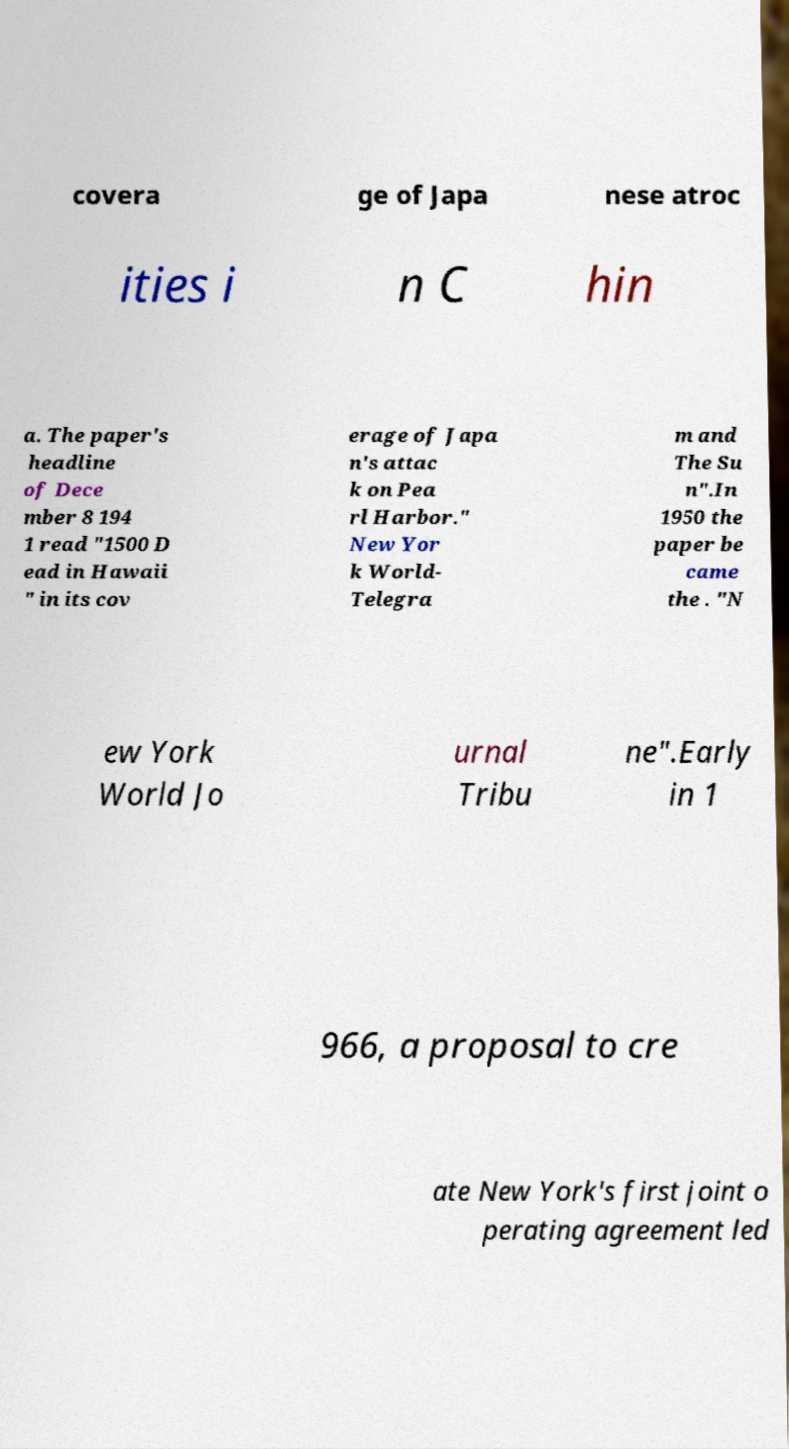Please identify and transcribe the text found in this image. covera ge of Japa nese atroc ities i n C hin a. The paper's headline of Dece mber 8 194 1 read "1500 D ead in Hawaii " in its cov erage of Japa n's attac k on Pea rl Harbor." New Yor k World- Telegra m and The Su n".In 1950 the paper be came the . "N ew York World Jo urnal Tribu ne".Early in 1 966, a proposal to cre ate New York's first joint o perating agreement led 